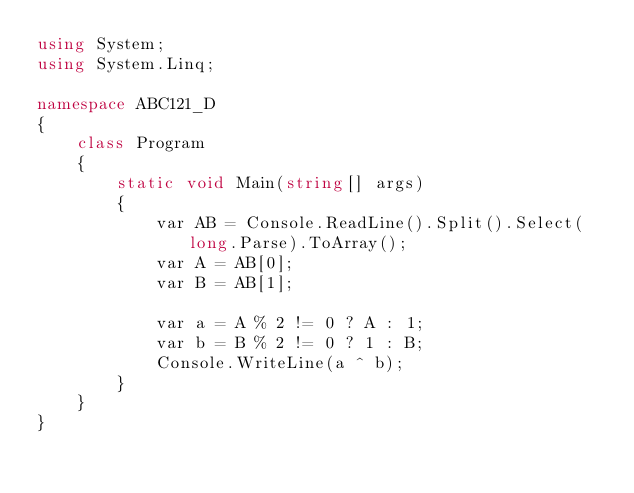<code> <loc_0><loc_0><loc_500><loc_500><_C#_>using System;
using System.Linq;

namespace ABC121_D
{
    class Program
    {
        static void Main(string[] args)
        {
            var AB = Console.ReadLine().Split().Select(long.Parse).ToArray();
            var A = AB[0];
            var B = AB[1];

            var a = A % 2 != 0 ? A : 1;
            var b = B % 2 != 0 ? 1 : B;
            Console.WriteLine(a ^ b);
        }
    }
}
</code> 